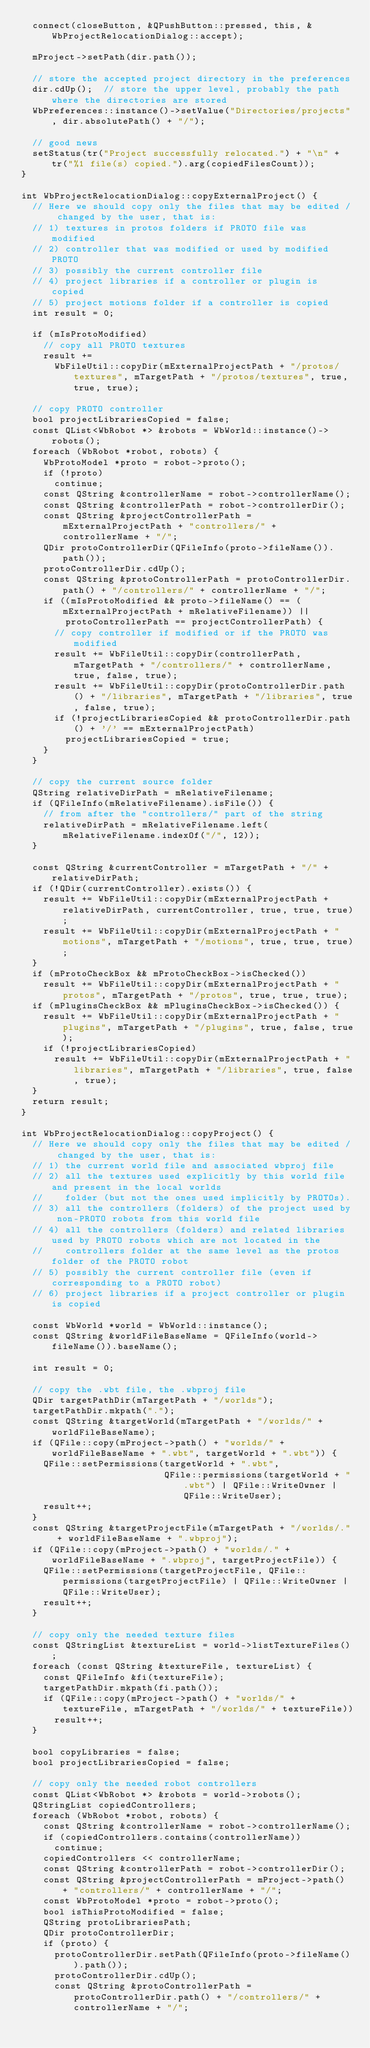Convert code to text. <code><loc_0><loc_0><loc_500><loc_500><_C++_>  connect(closeButton, &QPushButton::pressed, this, &WbProjectRelocationDialog::accept);

  mProject->setPath(dir.path());

  // store the accepted project directory in the preferences
  dir.cdUp();  // store the upper level, probably the path where the directories are stored
  WbPreferences::instance()->setValue("Directories/projects", dir.absolutePath() + "/");

  // good news
  setStatus(tr("Project successfully relocated.") + "\n" + tr("%1 file(s) copied.").arg(copiedFilesCount));
}

int WbProjectRelocationDialog::copyExternalProject() {
  // Here we should copy only the files that may be edited / changed by the user, that is:
  // 1) textures in protos folders if PROTO file was modified
  // 2) controller that was modified or used by modified PROTO
  // 3) possibly the current controller file
  // 4) project libraries if a controller or plugin is copied
  // 5) project motions folder if a controller is copied
  int result = 0;

  if (mIsProtoModified)
    // copy all PROTO textures
    result +=
      WbFileUtil::copyDir(mExternalProjectPath + "/protos/textures", mTargetPath + "/protos/textures", true, true, true);

  // copy PROTO controller
  bool projectLibrariesCopied = false;
  const QList<WbRobot *> &robots = WbWorld::instance()->robots();
  foreach (WbRobot *robot, robots) {
    WbProtoModel *proto = robot->proto();
    if (!proto)
      continue;
    const QString &controllerName = robot->controllerName();
    const QString &controllerPath = robot->controllerDir();
    const QString &projectControllerPath = mExternalProjectPath + "controllers/" + controllerName + "/";
    QDir protoControllerDir(QFileInfo(proto->fileName()).path());
    protoControllerDir.cdUp();
    const QString &protoControllerPath = protoControllerDir.path() + "/controllers/" + controllerName + "/";
    if ((mIsProtoModified && proto->fileName() == (mExternalProjectPath + mRelativeFilename)) ||
        protoControllerPath == projectControllerPath) {
      // copy controller if modified or if the PROTO was modified
      result += WbFileUtil::copyDir(controllerPath, mTargetPath + "/controllers/" + controllerName, true, false, true);
      result += WbFileUtil::copyDir(protoControllerDir.path() + "/libraries", mTargetPath + "/libraries", true, false, true);
      if (!projectLibrariesCopied && protoControllerDir.path() + '/' == mExternalProjectPath)
        projectLibrariesCopied = true;
    }
  }

  // copy the current source folder
  QString relativeDirPath = mRelativeFilename;
  if (QFileInfo(mRelativeFilename).isFile()) {
    // from after the "controllers/" part of the string
    relativeDirPath = mRelativeFilename.left(mRelativeFilename.indexOf("/", 12));
  }

  const QString &currentController = mTargetPath + "/" + relativeDirPath;
  if (!QDir(currentController).exists()) {
    result += WbFileUtil::copyDir(mExternalProjectPath + relativeDirPath, currentController, true, true, true);
    result += WbFileUtil::copyDir(mExternalProjectPath + "motions", mTargetPath + "/motions", true, true, true);
  }
  if (mProtoCheckBox && mProtoCheckBox->isChecked())
    result += WbFileUtil::copyDir(mExternalProjectPath + "protos", mTargetPath + "/protos", true, true, true);
  if (mPluginsCheckBox && mPluginsCheckBox->isChecked()) {
    result += WbFileUtil::copyDir(mExternalProjectPath + "plugins", mTargetPath + "/plugins", true, false, true);
    if (!projectLibrariesCopied)
      result += WbFileUtil::copyDir(mExternalProjectPath + "libraries", mTargetPath + "/libraries", true, false, true);
  }
  return result;
}

int WbProjectRelocationDialog::copyProject() {
  // Here we should copy only the files that may be edited / changed by the user, that is:
  // 1) the current world file and associated wbproj file
  // 2) all the textures used explicitly by this world file and present in the local worlds
  //    folder (but not the ones used implicitly by PROTOs).
  // 3) all the controllers (folders) of the project used by non-PROTO robots from this world file
  // 4) all the controllers (folders) and related libraries used by PROTO robots which are not located in the
  //    controllers folder at the same level as the protos folder of the PROTO robot
  // 5) possibly the current controller file (even if corresponding to a PROTO robot)
  // 6) project libraries if a project controller or plugin is copied

  const WbWorld *world = WbWorld::instance();
  const QString &worldFileBaseName = QFileInfo(world->fileName()).baseName();

  int result = 0;

  // copy the .wbt file, the .wbproj file
  QDir targetPathDir(mTargetPath + "/worlds");
  targetPathDir.mkpath(".");
  const QString &targetWorld(mTargetPath + "/worlds/" + worldFileBaseName);
  if (QFile::copy(mProject->path() + "worlds/" + worldFileBaseName + ".wbt", targetWorld + ".wbt")) {
    QFile::setPermissions(targetWorld + ".wbt",
                          QFile::permissions(targetWorld + ".wbt") | QFile::WriteOwner | QFile::WriteUser);
    result++;
  }
  const QString &targetProjectFile(mTargetPath + "/worlds/." + worldFileBaseName + ".wbproj");
  if (QFile::copy(mProject->path() + "worlds/." + worldFileBaseName + ".wbproj", targetProjectFile)) {
    QFile::setPermissions(targetProjectFile, QFile::permissions(targetProjectFile) | QFile::WriteOwner | QFile::WriteUser);
    result++;
  }

  // copy only the needed texture files
  const QStringList &textureList = world->listTextureFiles();
  foreach (const QString &textureFile, textureList) {
    const QFileInfo &fi(textureFile);
    targetPathDir.mkpath(fi.path());
    if (QFile::copy(mProject->path() + "worlds/" + textureFile, mTargetPath + "/worlds/" + textureFile))
      result++;
  }

  bool copyLibraries = false;
  bool projectLibrariesCopied = false;

  // copy only the needed robot controllers
  const QList<WbRobot *> &robots = world->robots();
  QStringList copiedControllers;
  foreach (WbRobot *robot, robots) {
    const QString &controllerName = robot->controllerName();
    if (copiedControllers.contains(controllerName))
      continue;
    copiedControllers << controllerName;
    const QString &controllerPath = robot->controllerDir();
    const QString &projectControllerPath = mProject->path() + "controllers/" + controllerName + "/";
    const WbProtoModel *proto = robot->proto();
    bool isThisProtoModified = false;
    QString protoLibrariesPath;
    QDir protoControllerDir;
    if (proto) {
      protoControllerDir.setPath(QFileInfo(proto->fileName()).path());
      protoControllerDir.cdUp();
      const QString &protoControllerPath = protoControllerDir.path() + "/controllers/" + controllerName + "/";</code> 